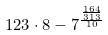Convert formula to latex. <formula><loc_0><loc_0><loc_500><loc_500>1 2 3 \cdot 8 - 7 ^ { \frac { \frac { 1 6 4 } { 3 1 3 } } { 1 0 } }</formula> 